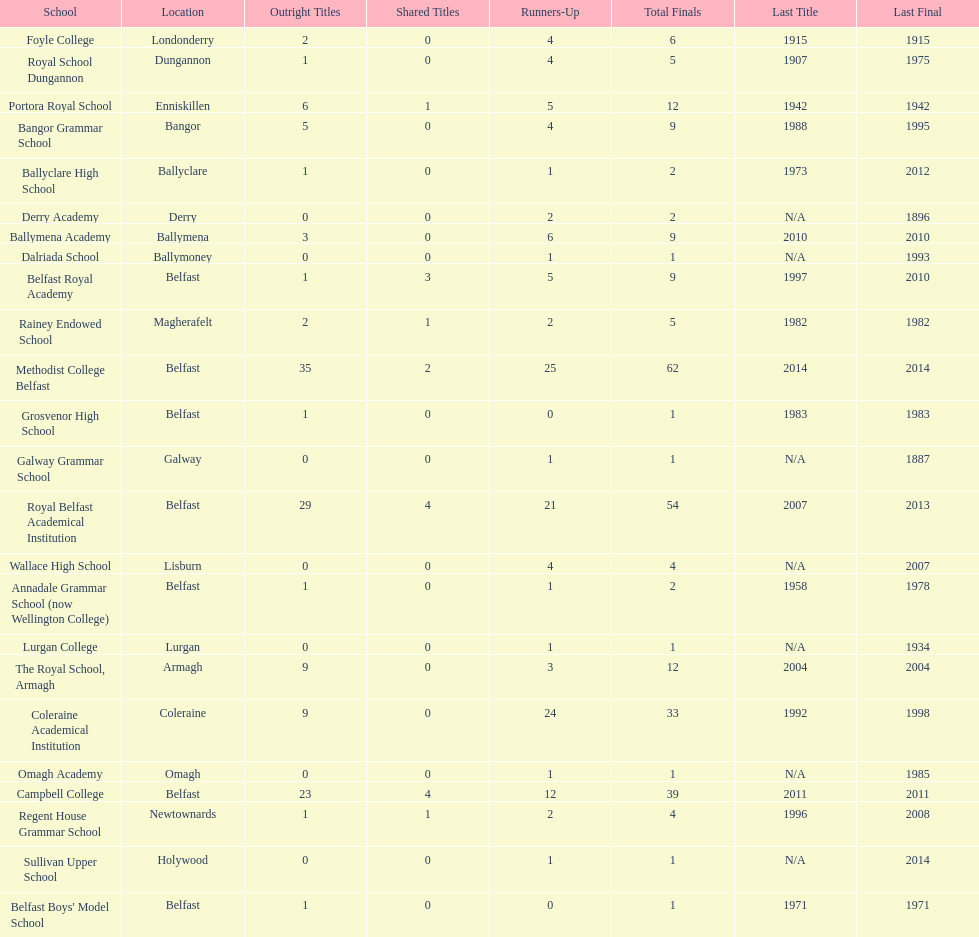Which schools hold the largest quantity of shared titles? Royal Belfast Academical Institution, Campbell College. 